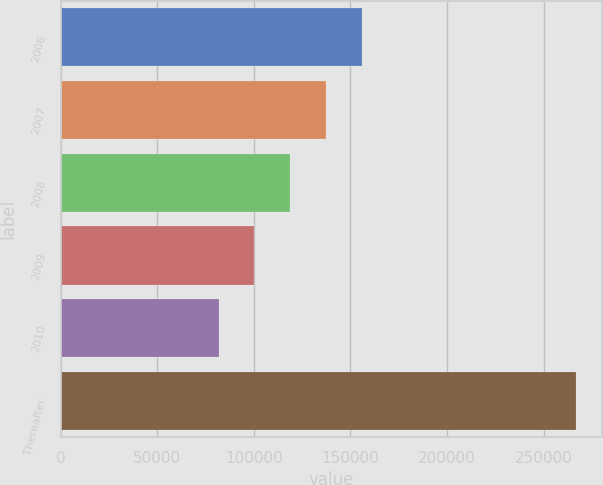<chart> <loc_0><loc_0><loc_500><loc_500><bar_chart><fcel>2006<fcel>2007<fcel>2008<fcel>2009<fcel>2010<fcel>Thereafter<nl><fcel>155761<fcel>137255<fcel>118749<fcel>100243<fcel>81737<fcel>266796<nl></chart> 